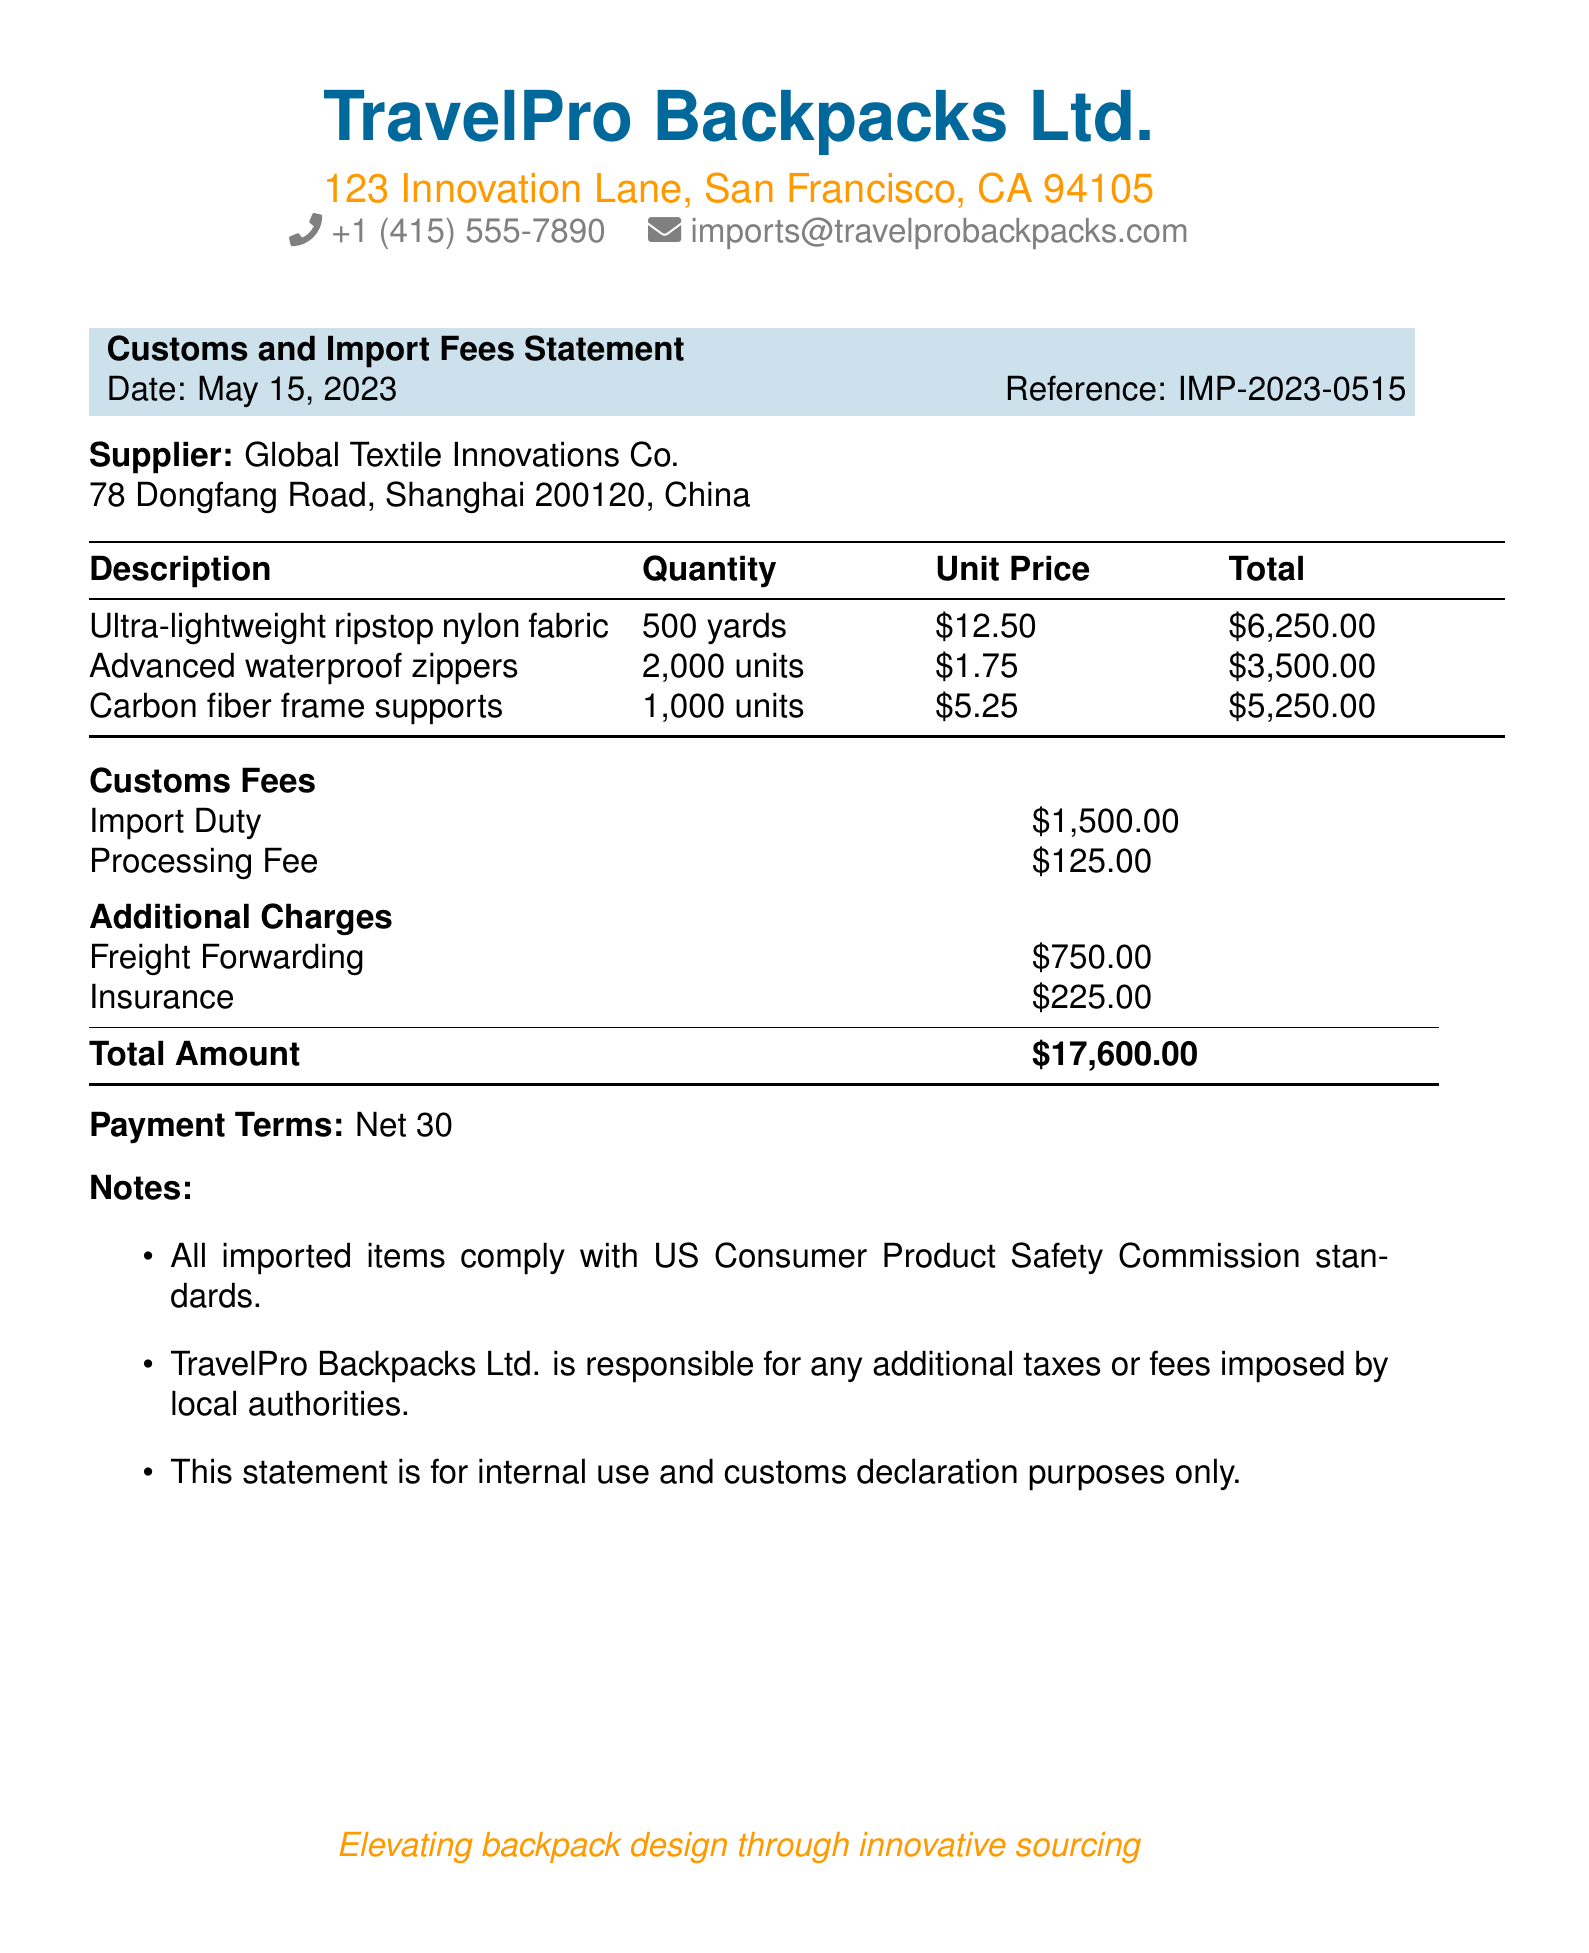what is the date of the statement? The date of the statement is mentioned in the header section of the document.
Answer: May 15, 2023 who is the supplier? The supplier's name is provided just below the document title.
Answer: Global Textile Innovations Co what is the total amount? The total amount is stated explicitly towards the bottom of the document.
Answer: $17,600.00 how many yards of fabric were ordered? The quantity of fabric ordered is specified in the components table.
Answer: 500 yards what is the import duty fee? The document lists the import duty fee as a specific line item under customs fees.
Answer: $1,500.00 what are the payment terms? The payment terms are described in a separate section near the end of the document.
Answer: Net 30 how many units of advanced waterproof zippers were ordered? The quantity of advanced waterproof zippers is detailed in the table of components.
Answer: 2,000 units what is the insurance amount charged? The insurance amount is listed under additional charges in the document.
Answer: $225.00 what is the purpose of this statement? The purpose of the statement is indicated in the notes section at the end of the document.
Answer: Internal use and customs declaration purposes only 